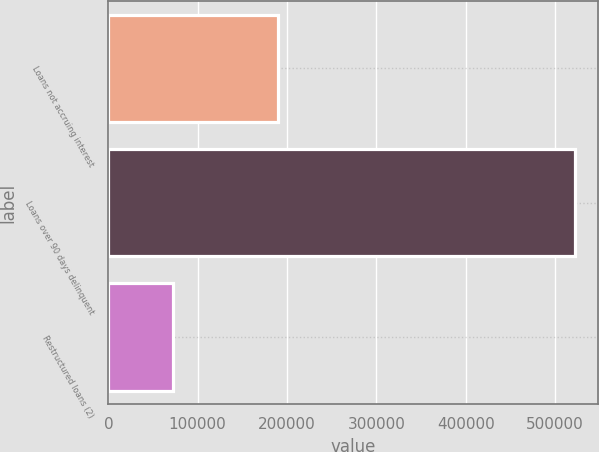Convert chart to OTSL. <chart><loc_0><loc_0><loc_500><loc_500><bar_chart><fcel>Loans not accruing interest<fcel>Loans over 90 days delinquent<fcel>Restructured loans (2)<nl><fcel>190086<fcel>522190<fcel>72924<nl></chart> 